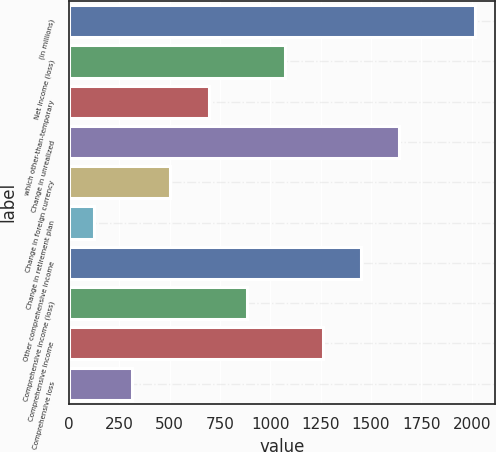Convert chart. <chart><loc_0><loc_0><loc_500><loc_500><bar_chart><fcel>(in millions)<fcel>Net income (loss)<fcel>which other-than-temporary<fcel>Change in unrealized<fcel>Change in foreign currency<fcel>Change in retirement plan<fcel>Other comprehensive income<fcel>Comprehensive income (loss)<fcel>Comprehensive income<fcel>Comprehensive loss<nl><fcel>2016<fcel>1071<fcel>693<fcel>1638<fcel>504<fcel>126<fcel>1449<fcel>882<fcel>1260<fcel>315<nl></chart> 